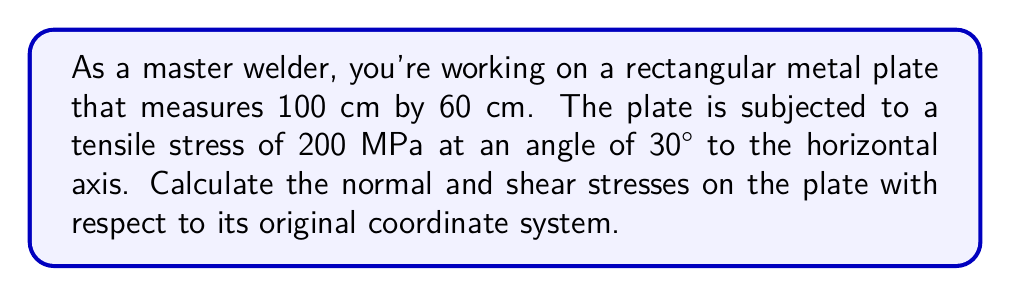Can you solve this math problem? To solve this problem, we need to use coordinate transformation equations for plane stress. Let's approach this step-by-step:

1) First, let's define our coordinate system:
   - x-axis: along the 100 cm side of the plate
   - y-axis: along the 60 cm side of the plate

2) The stress components in the rotated coordinate system (x', y') are:
   $\sigma_x' = 200$ MPa
   $\sigma_y' = 0$ MPa
   $\tau_{x'y'} = 0$ MPa

3) The angle between the x-axis and x'-axis is 30°. We'll use this in our transformation equations.

4) The transformation equations for plane stress are:

   $$\sigma_x = \sigma_x' \cos^2\theta + \sigma_y' \sin^2\theta + 2\tau_{x'y'} \sin\theta \cos\theta$$
   $$\sigma_y = \sigma_x' \sin^2\theta + \sigma_y' \cos^2\theta - 2\tau_{x'y'} \sin\theta \cos\theta$$
   $$\tau_{xy} = (\sigma_y' - \sigma_x') \sin\theta \cos\theta + \tau_{x'y'} (\cos^2\theta - \sin^2\theta)$$

5) Substituting our values:

   $$\sigma_x = 200 \cos^2(30°) + 0 \sin^2(30°) + 2(0) \sin(30°) \cos(30°)$$
   $$\sigma_y = 200 \sin^2(30°) + 0 \cos^2(30°) - 2(0) \sin(30°) \cos(30°)$$
   $$\tau_{xy} = (0 - 200) \sin(30°) \cos(30°) + 0 (\cos^2(30°) - \sin^2(30°))$$

6) Simplifying:

   $$\sigma_x = 200 (\frac{\sqrt{3}}{2})^2 = 200 \cdot \frac{3}{4} = 150 \text{ MPa}$$
   $$\sigma_y = 200 (\frac{1}{2})^2 = 200 \cdot \frac{1}{4} = 50 \text{ MPa}$$
   $$\tau_{xy} = -200 \cdot \frac{\sqrt{3}}{2} \cdot \frac{1}{2} = -50 \sqrt{3} \text{ MPa}$$

Therefore, the normal stresses are 150 MPa in the x-direction and 50 MPa in the y-direction, and the shear stress is -50√3 MPa.
Answer: $\sigma_x = 150 \text{ MPa}$, $\sigma_y = 50 \text{ MPa}$, $\tau_{xy} = -50\sqrt{3} \text{ MPa}$ 